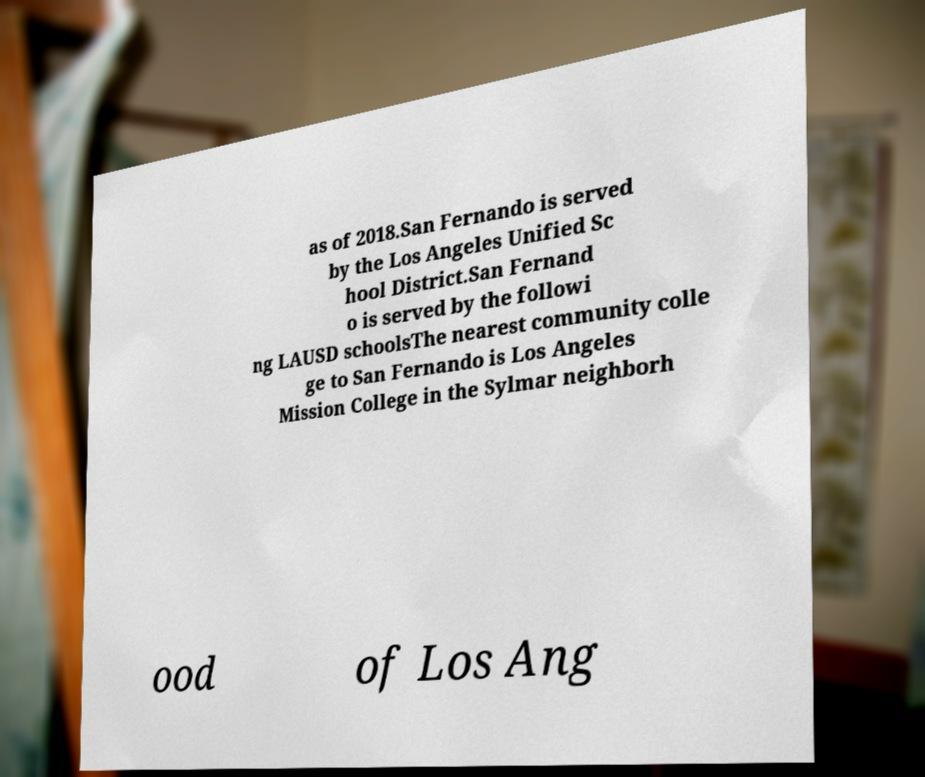Please identify and transcribe the text found in this image. as of 2018.San Fernando is served by the Los Angeles Unified Sc hool District.San Fernand o is served by the followi ng LAUSD schoolsThe nearest community colle ge to San Fernando is Los Angeles Mission College in the Sylmar neighborh ood of Los Ang 